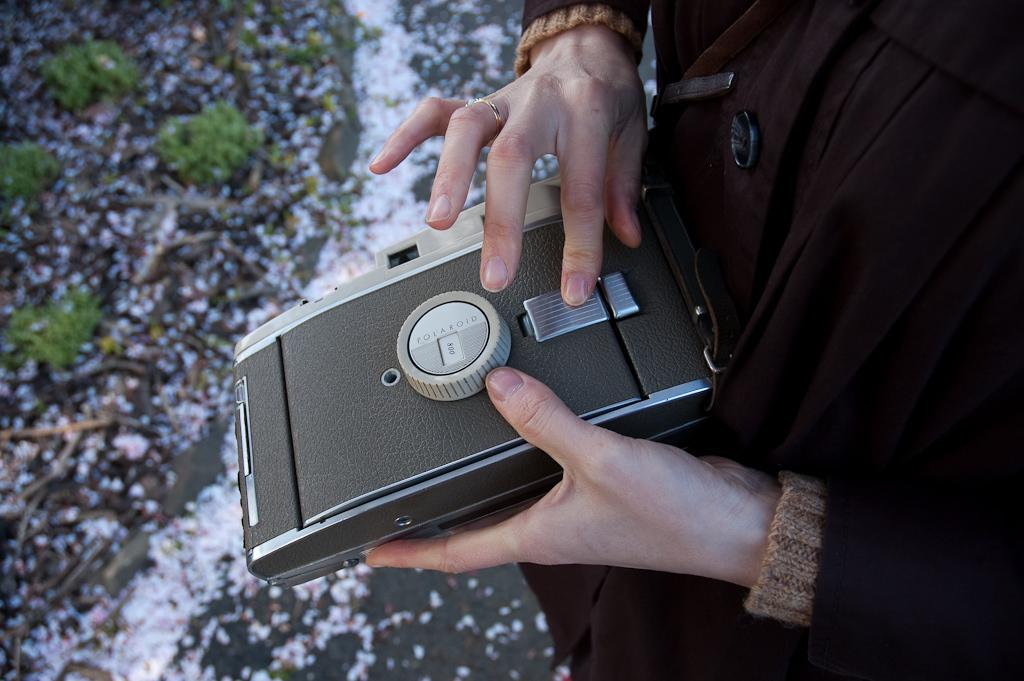What can be seen in the image? There is a person in the image. What is the person doing in the image? The person is holding an object with their hands. Where is the object located in the image? The object is on the right side of the image. Can you describe the area on the left side of the image? There is a blurred area on the left side of the image. What type of basketball trick is the person performing in the image? There is no basketball or trick present in the image; it only features a person holding an object. 